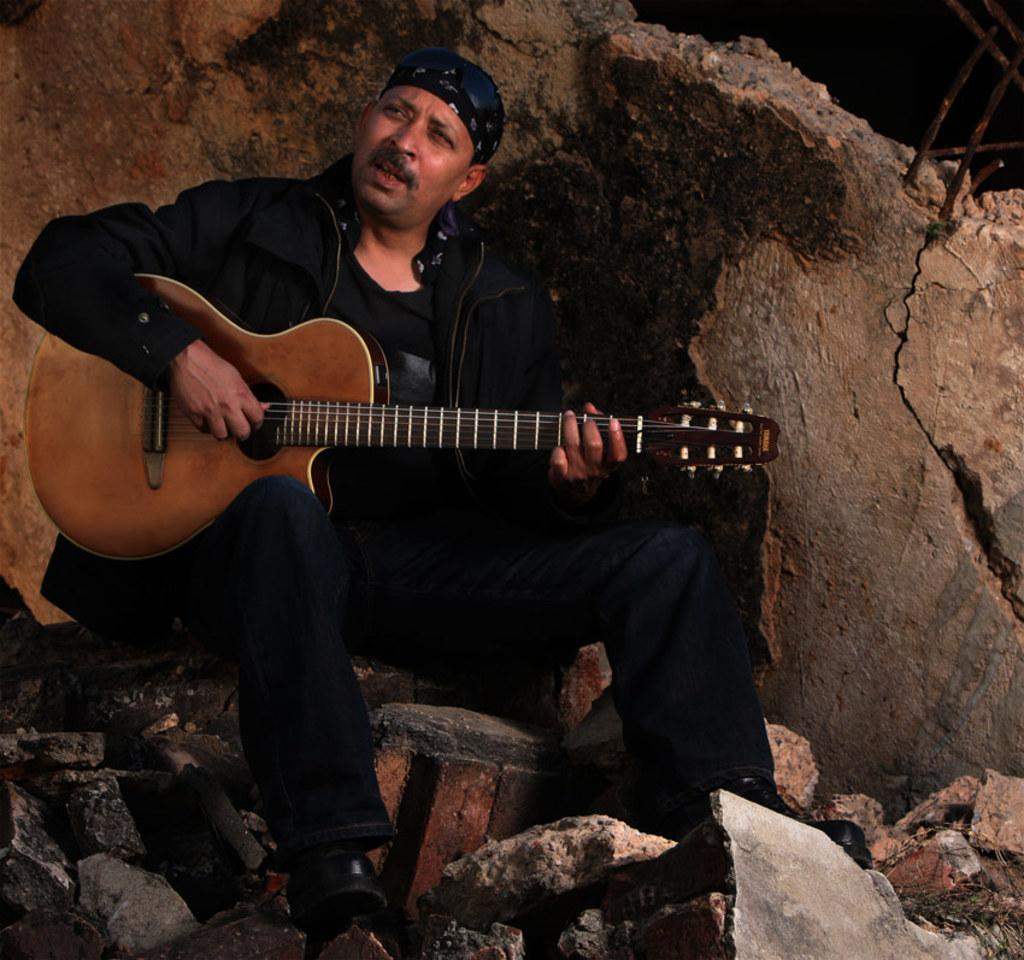Who is the person in the image? There is a man in the image. What is the man doing in the image? The man is playing a guitar. What is the man wearing in the image? The man is wearing a black dress and has a cap on his head. What is the man sitting on in the image? The man is sitting on rocks. What color is the guitar the man is playing? The guitar is brown in color. What direction is the man facing in the image? The provided facts do not mention the direction the man is facing, so it cannot be determined from the image. 